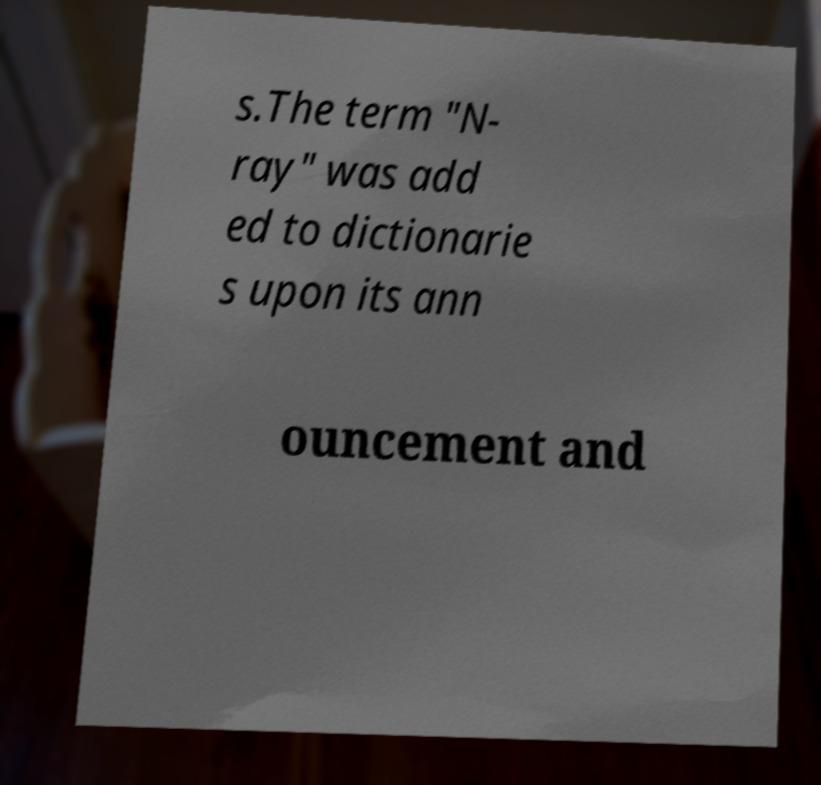Could you extract and type out the text from this image? s.The term "N- ray" was add ed to dictionarie s upon its ann ouncement and 